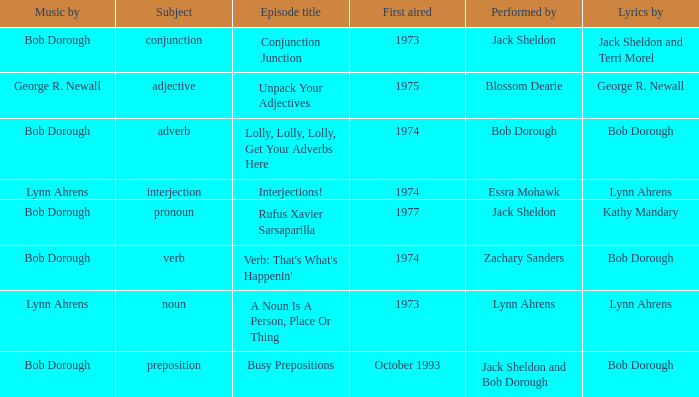When zachary sanders is the performer how many first aired are there? 1.0. 